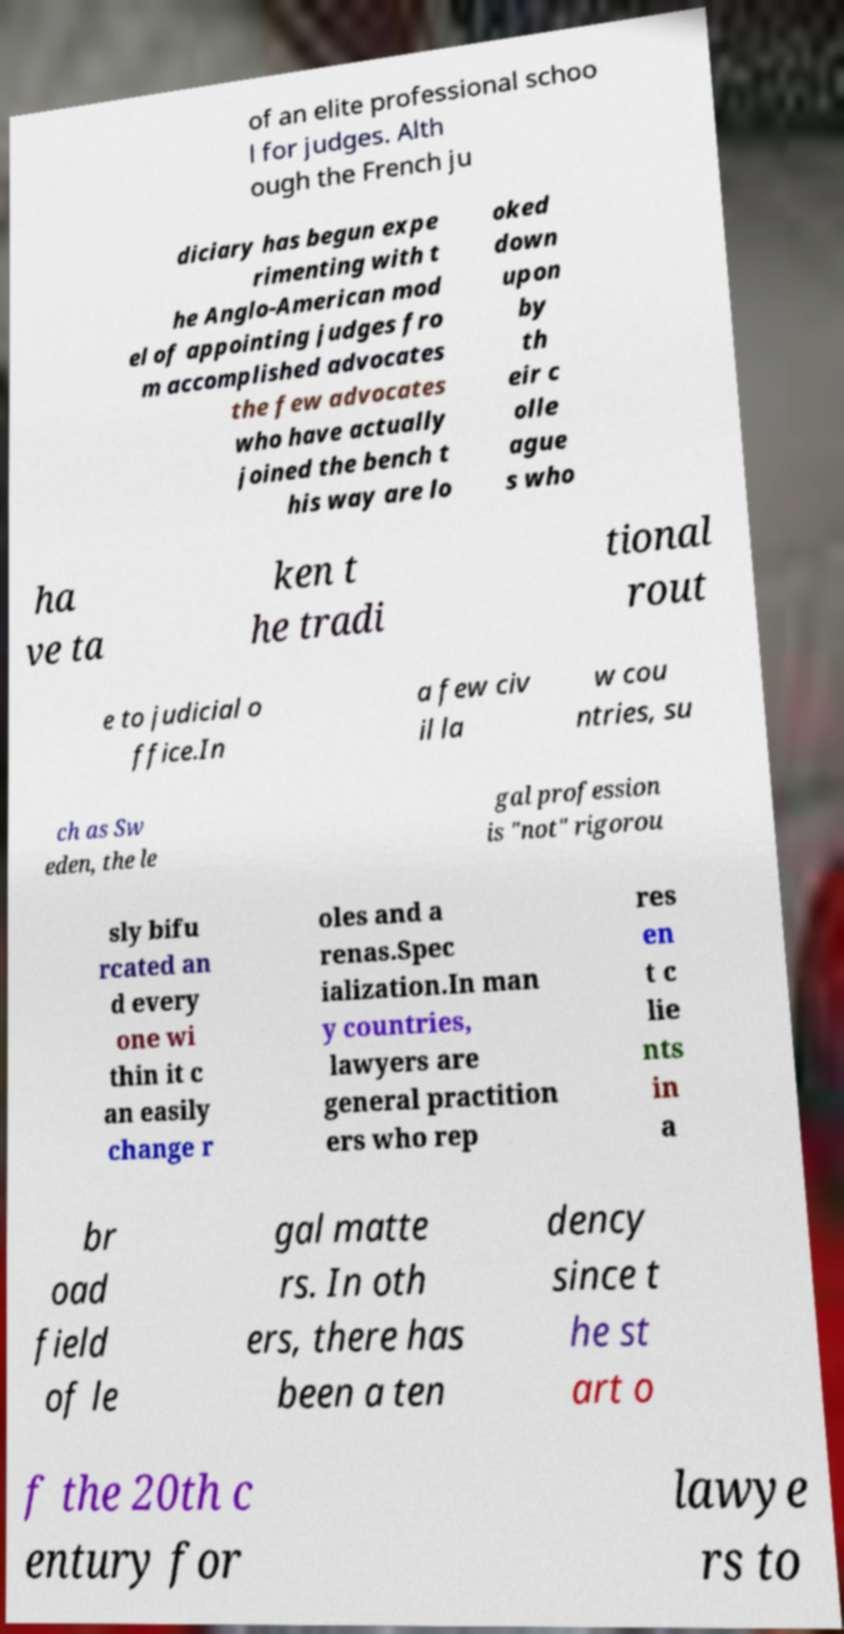What might be the significance of the use of different colors for some words in the text? The different colors used in the document could serve several purposes. One possibility is to highlight key terms or concepts that are important within the discussion of the subject matter. Another possibility is that the colors are used to organize or categorize information in a visual way, aiding the reader in navigating through complex topics or distinguishing between different threads of discussion. 